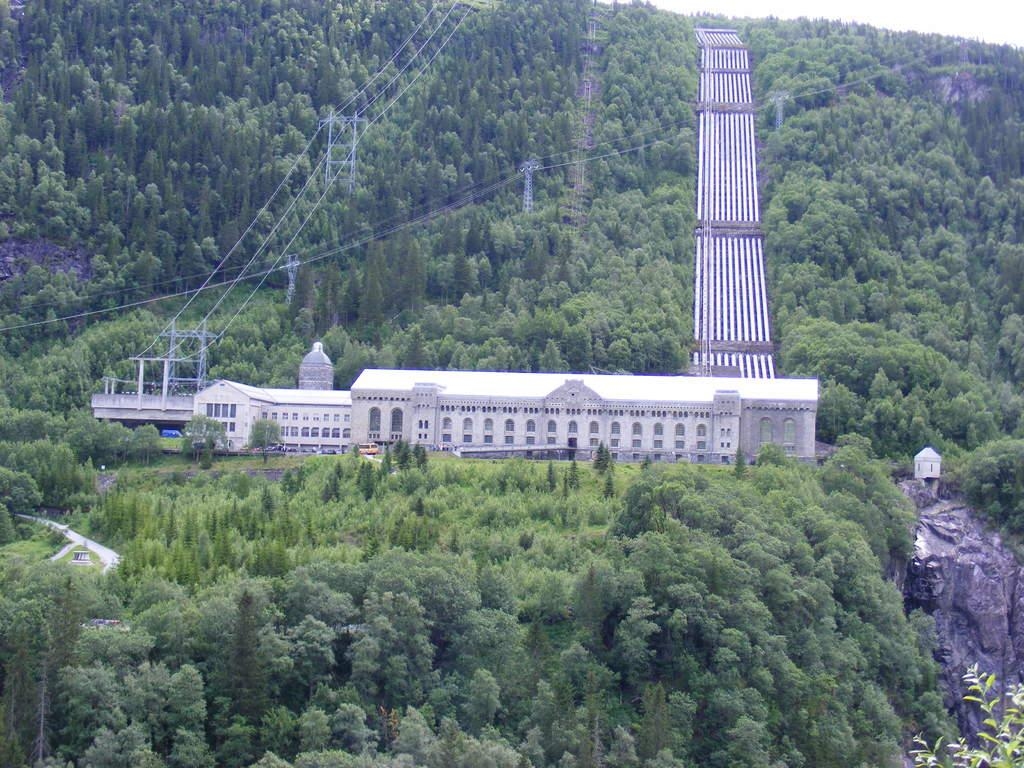What type of structure is visible in the image? There is a building in the image. What are the ropes used for in the image? The purpose of the ropes in the image is not specified, but they are likely used for climbing or securing objects. How many towers can be seen in the image? There are towers in the image, but the exact number is not specified. What type of vegetation is present in the image? There are trees in the image. What type of pathways are visible in the image? There are roads in the image. What type of natural formation is present in the image? There are rocks in the image. What time of day is depicted in the image? The time of day is not specified in the image, as there are no indicators such as shadows or lighting to suggest a particular time. Who is the creator of the building in the image? The creator of the building is not specified in the image, as there is no information about its origin or architect. 